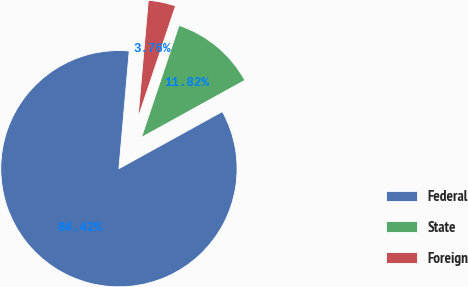<chart> <loc_0><loc_0><loc_500><loc_500><pie_chart><fcel>Federal<fcel>State<fcel>Foreign<nl><fcel>84.42%<fcel>11.82%<fcel>3.76%<nl></chart> 